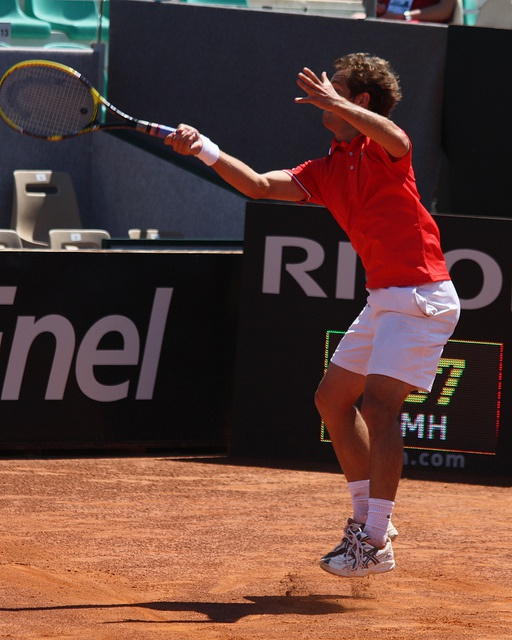Describe the objects in this image and their specific colors. I can see people in teal, maroon, black, and gray tones, tennis racket in teal and black tones, chair in teal, black, gray, and darkgray tones, chair in teal and lightblue tones, and people in teal, maroon, black, and gray tones in this image. 